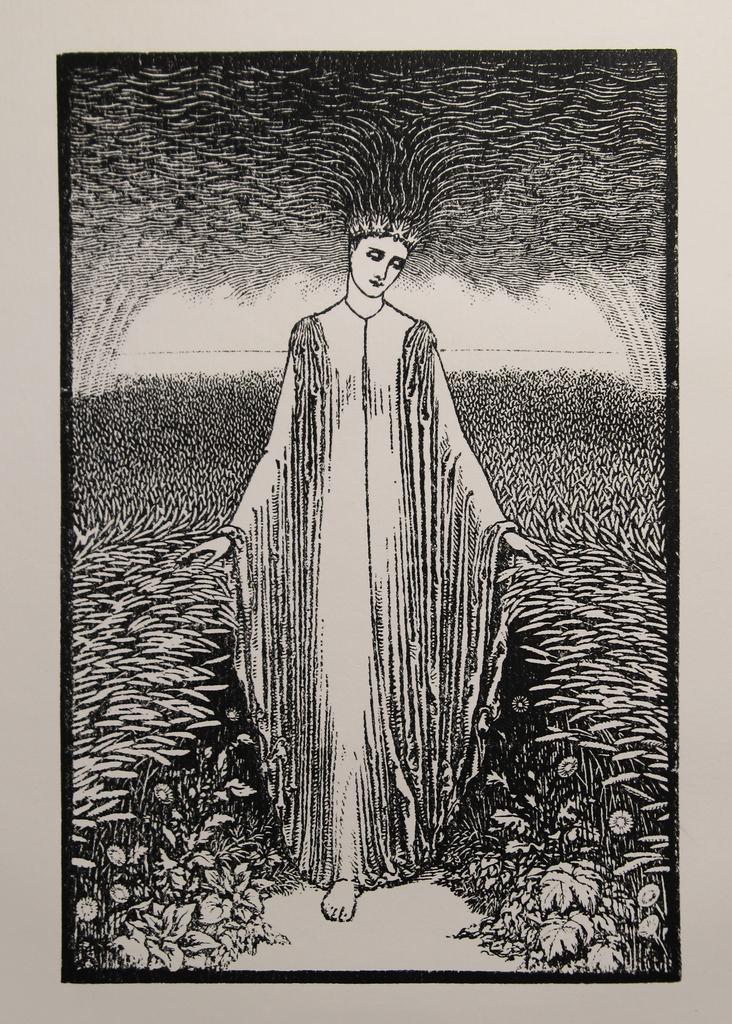How would you summarize this image in a sentence or two? Here we can see a photo frame on a platform and in the photo frame we can see the drawing of a woman standing on the path and to either side of her there are plants. 